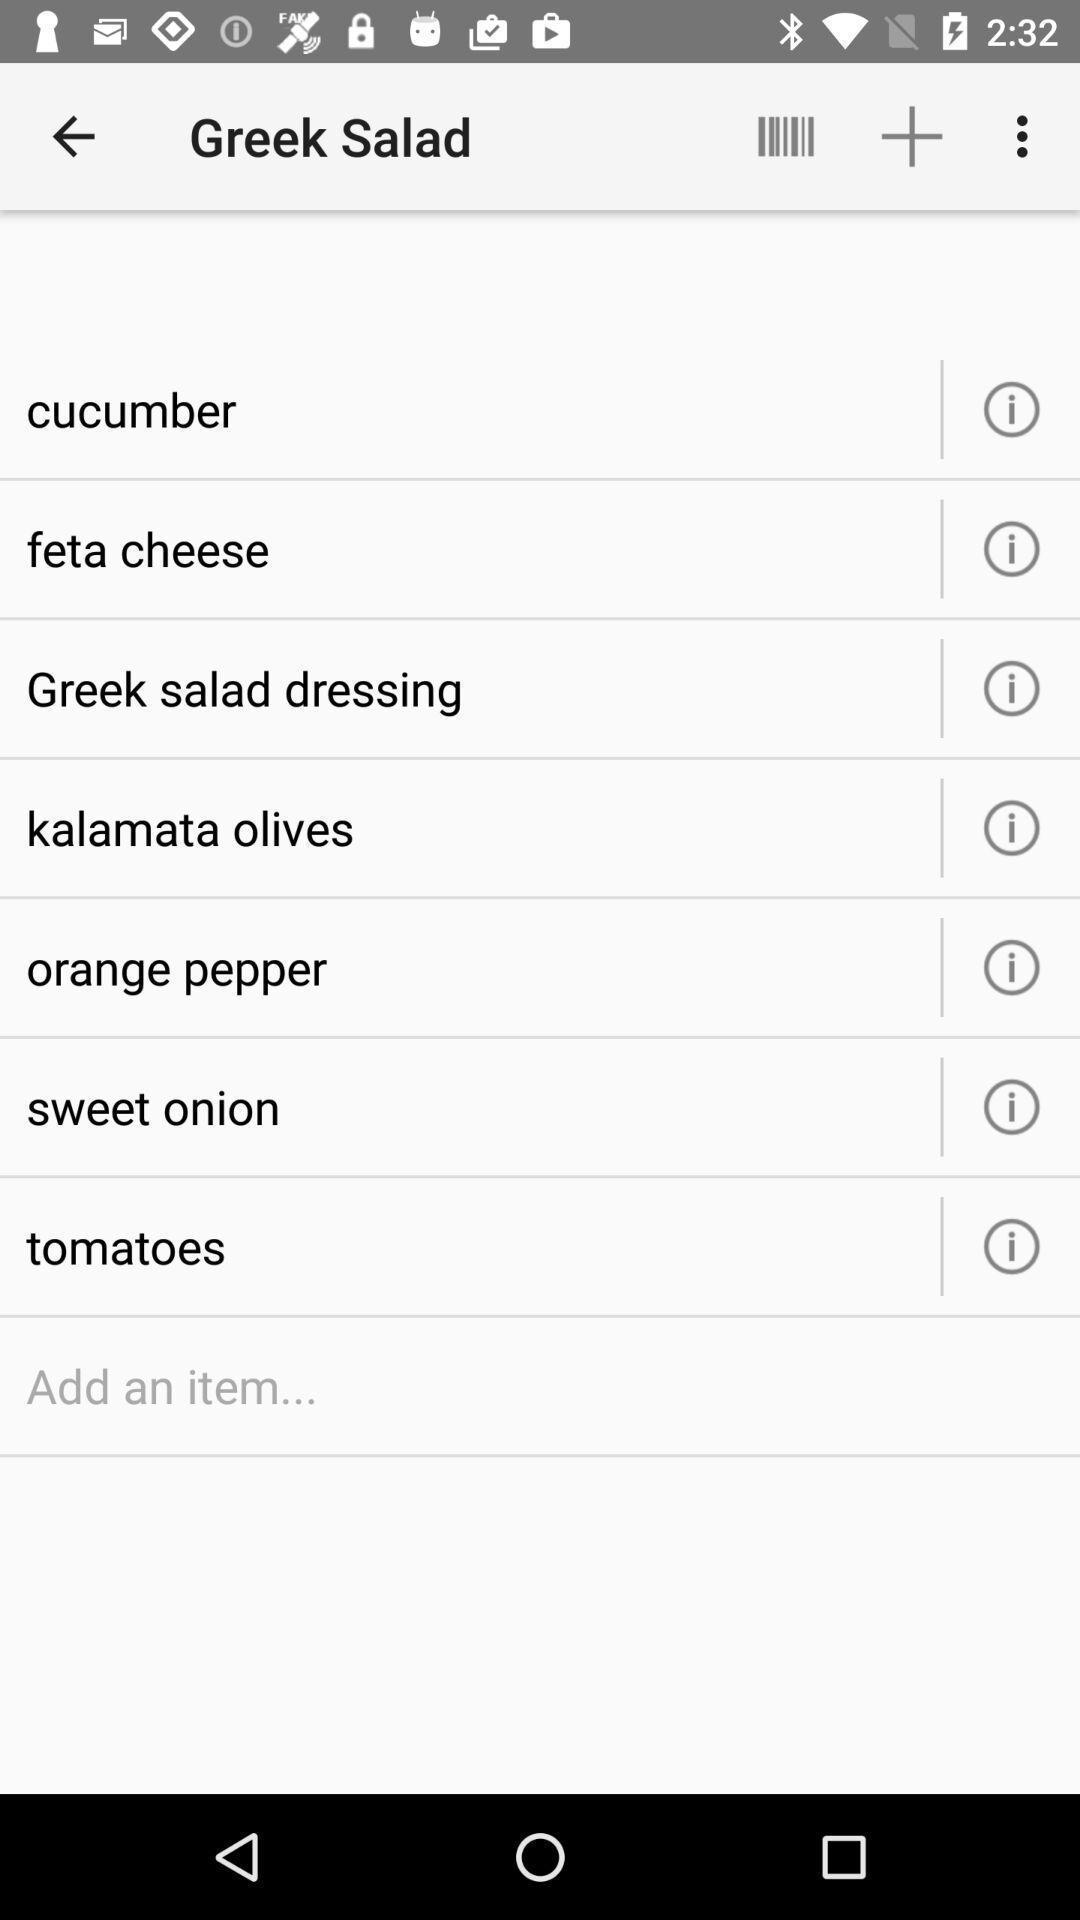What can you discern from this picture? Page showing menu with multiple icons. 